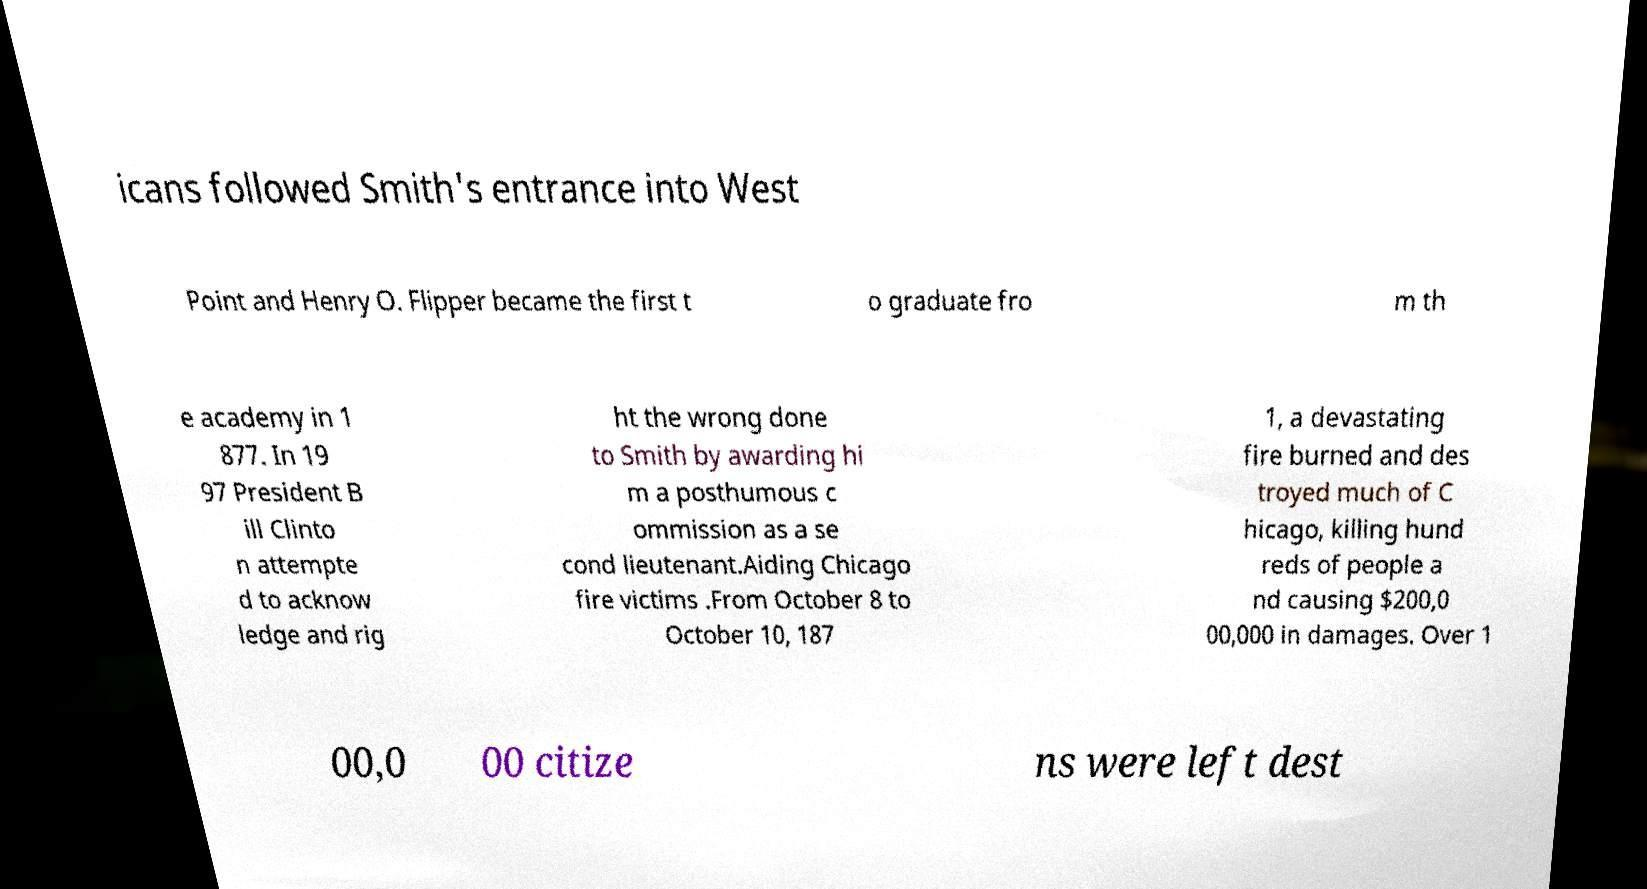There's text embedded in this image that I need extracted. Can you transcribe it verbatim? icans followed Smith's entrance into West Point and Henry O. Flipper became the first t o graduate fro m th e academy in 1 877. In 19 97 President B ill Clinto n attempte d to acknow ledge and rig ht the wrong done to Smith by awarding hi m a posthumous c ommission as a se cond lieutenant.Aiding Chicago fire victims .From October 8 to October 10, 187 1, a devastating fire burned and des troyed much of C hicago, killing hund reds of people a nd causing $200,0 00,000 in damages. Over 1 00,0 00 citize ns were left dest 